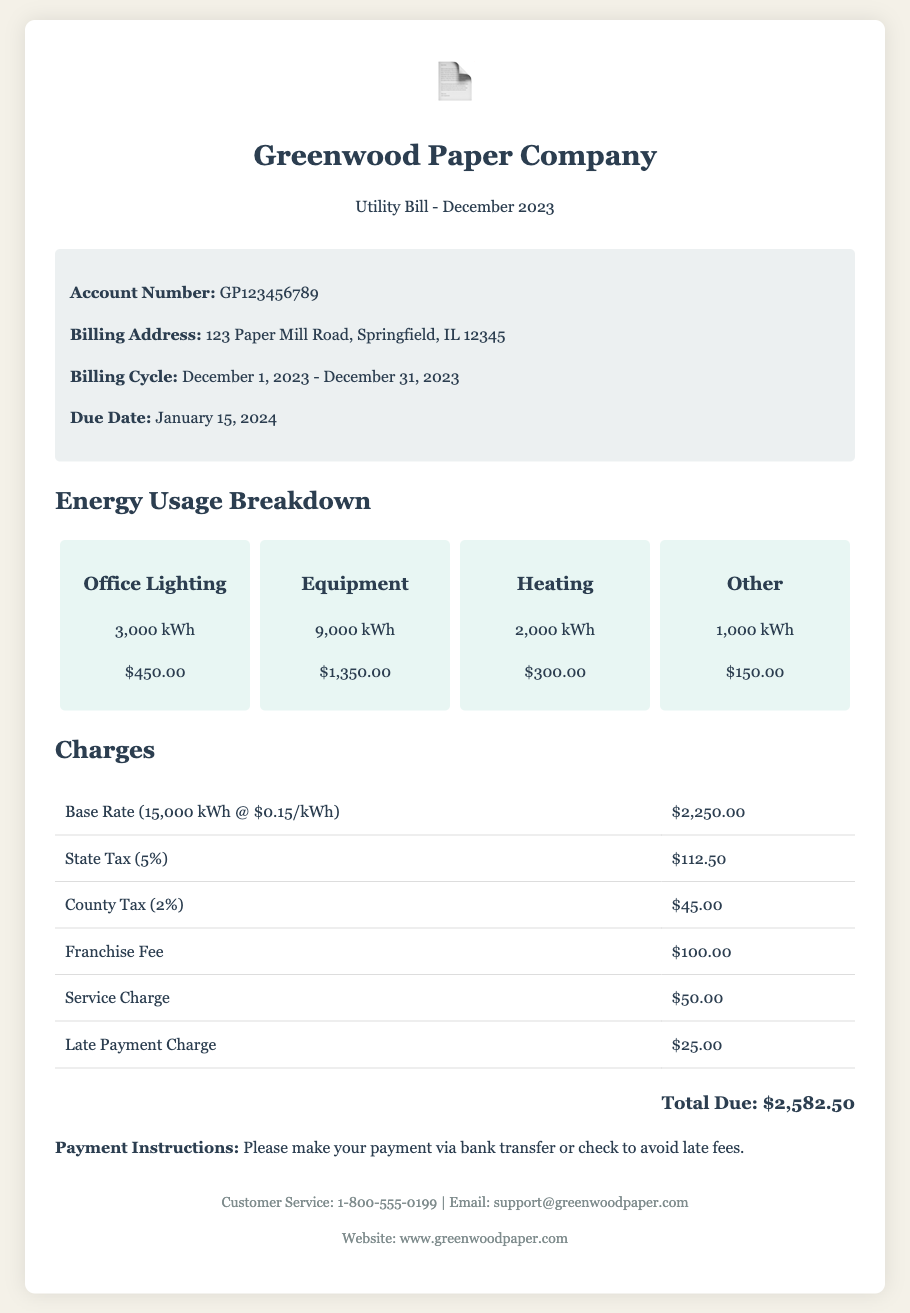What is the account number? The account number is specifically mentioned in the account info section of the document.
Answer: GP123456789 What is the total due amount? The total due amount is indicated at the bottom of the bill as the final payment required.
Answer: $2,582.50 How much was charged for Equipment usage? The Equipment charge is detailed in the energy usage breakdown with the corresponding amount due.
Answer: $1,350.00 What is the due date for payment? The due date is provided in the account info section, indicating when the payment should be made.
Answer: January 15, 2024 What percentage is the state tax? The percentage of the state tax is written in the charges section for clarity on the applicable tax rate.
Answer: 5% How much energy was used for Office Lighting? The energy usage for Office Lighting is defined in the breakdown of energy usage along with the corresponding charge.
Answer: 3,000 kWh What is the amount of the late payment charge? The late payment charge is explicitly mentioned in the charges table, indicating any additional fees for late payments.
Answer: $25.00 What is the franchise fee amount? The amount for the franchise fee is listed in the charges section, providing insight into additional costs.
Answer: $100.00 What is the billing address? The billing address is detailed in the account info section, specifying where the bill is directed.
Answer: 123 Paper Mill Road, Springfield, IL 12345 